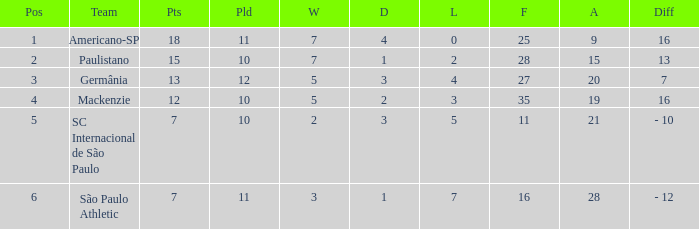Name the least for when played is 12 27.0. 